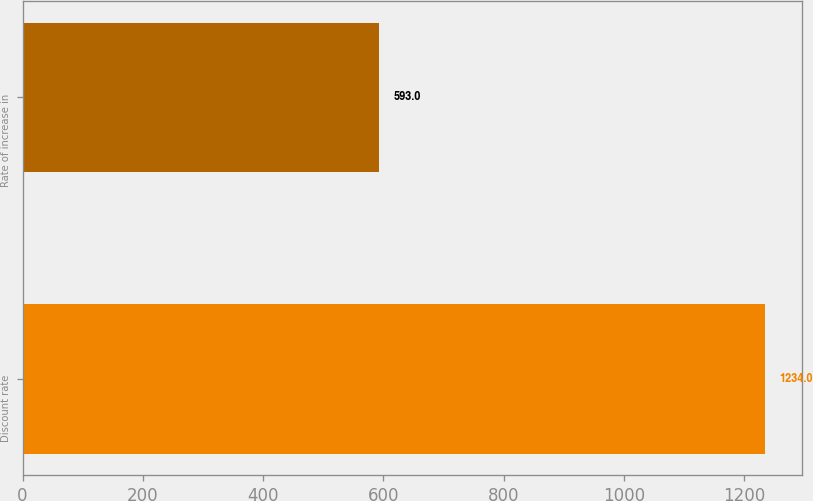Convert chart. <chart><loc_0><loc_0><loc_500><loc_500><bar_chart><fcel>Discount rate<fcel>Rate of increase in<nl><fcel>1234<fcel>593<nl></chart> 